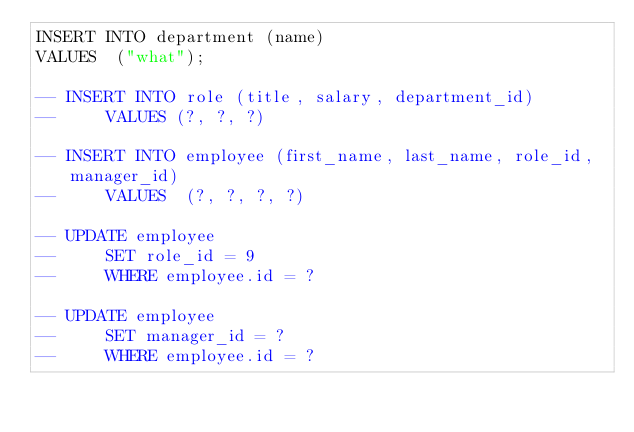Convert code to text. <code><loc_0><loc_0><loc_500><loc_500><_SQL_>INSERT INTO department (name)
VALUES  ("what");

-- INSERT INTO role (title, salary, department_id)
--     VALUES (?, ?, ?)

-- INSERT INTO employee (first_name, last_name, role_id, manager_id)
--     VALUES  (?, ?, ?, ?)

-- UPDATE employee
--     SET role_id = 9
--     WHERE employee.id = ?

-- UPDATE employee
--     SET manager_id = ?
--     WHERE employee.id = ?</code> 